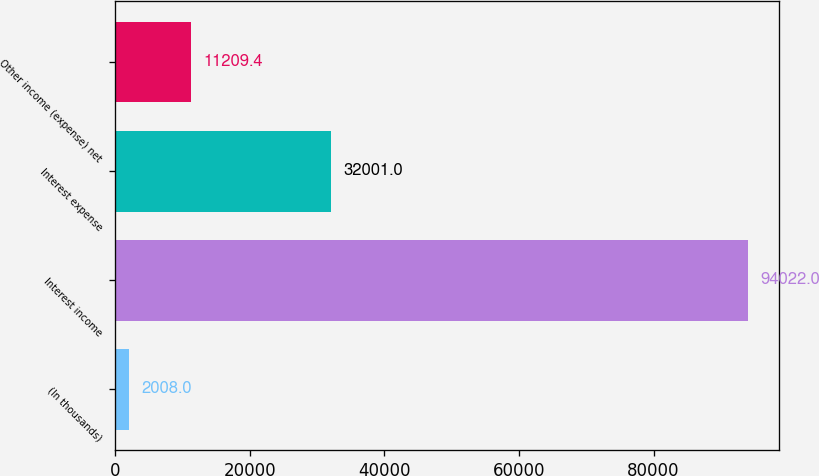<chart> <loc_0><loc_0><loc_500><loc_500><bar_chart><fcel>(In thousands)<fcel>Interest income<fcel>Interest expense<fcel>Other income (expense) net<nl><fcel>2008<fcel>94022<fcel>32001<fcel>11209.4<nl></chart> 